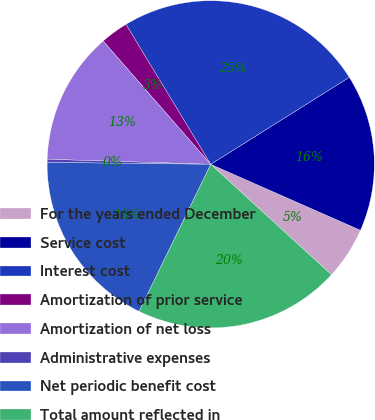<chart> <loc_0><loc_0><loc_500><loc_500><pie_chart><fcel>For the years ended December<fcel>Service cost<fcel>Interest cost<fcel>Amortization of prior service<fcel>Amortization of net loss<fcel>Administrative expenses<fcel>Net periodic benefit cost<fcel>Total amount reflected in<nl><fcel>5.19%<fcel>15.53%<fcel>24.75%<fcel>2.75%<fcel>13.09%<fcel>0.31%<fcel>17.97%<fcel>20.42%<nl></chart> 